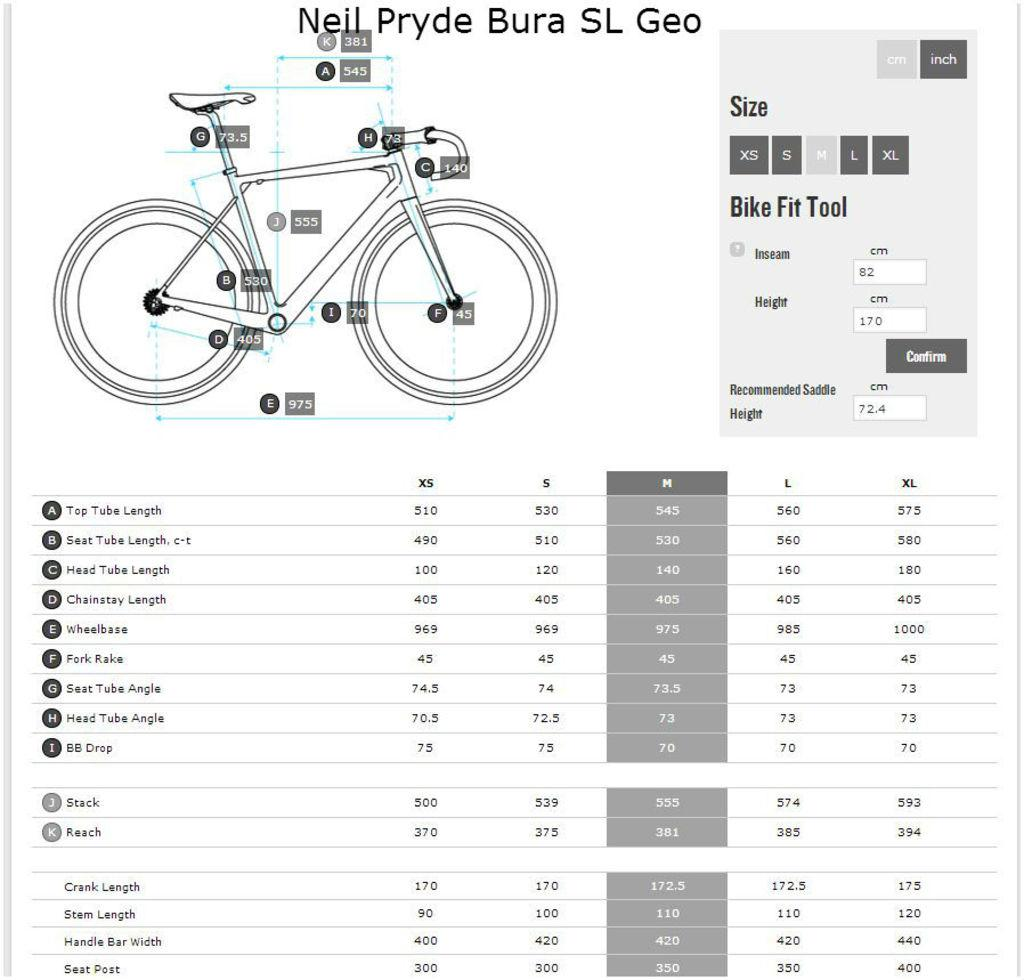What is depicted at the top side of the image? There is a diagram of a bicycle at the top side of the image. What else can be found in the image besides the bicycle diagram? There are texts and numbers in the image. What type of board game is being played in the image? There is no board game present in the image; it features a diagram of a bicycle, texts, and numbers. 